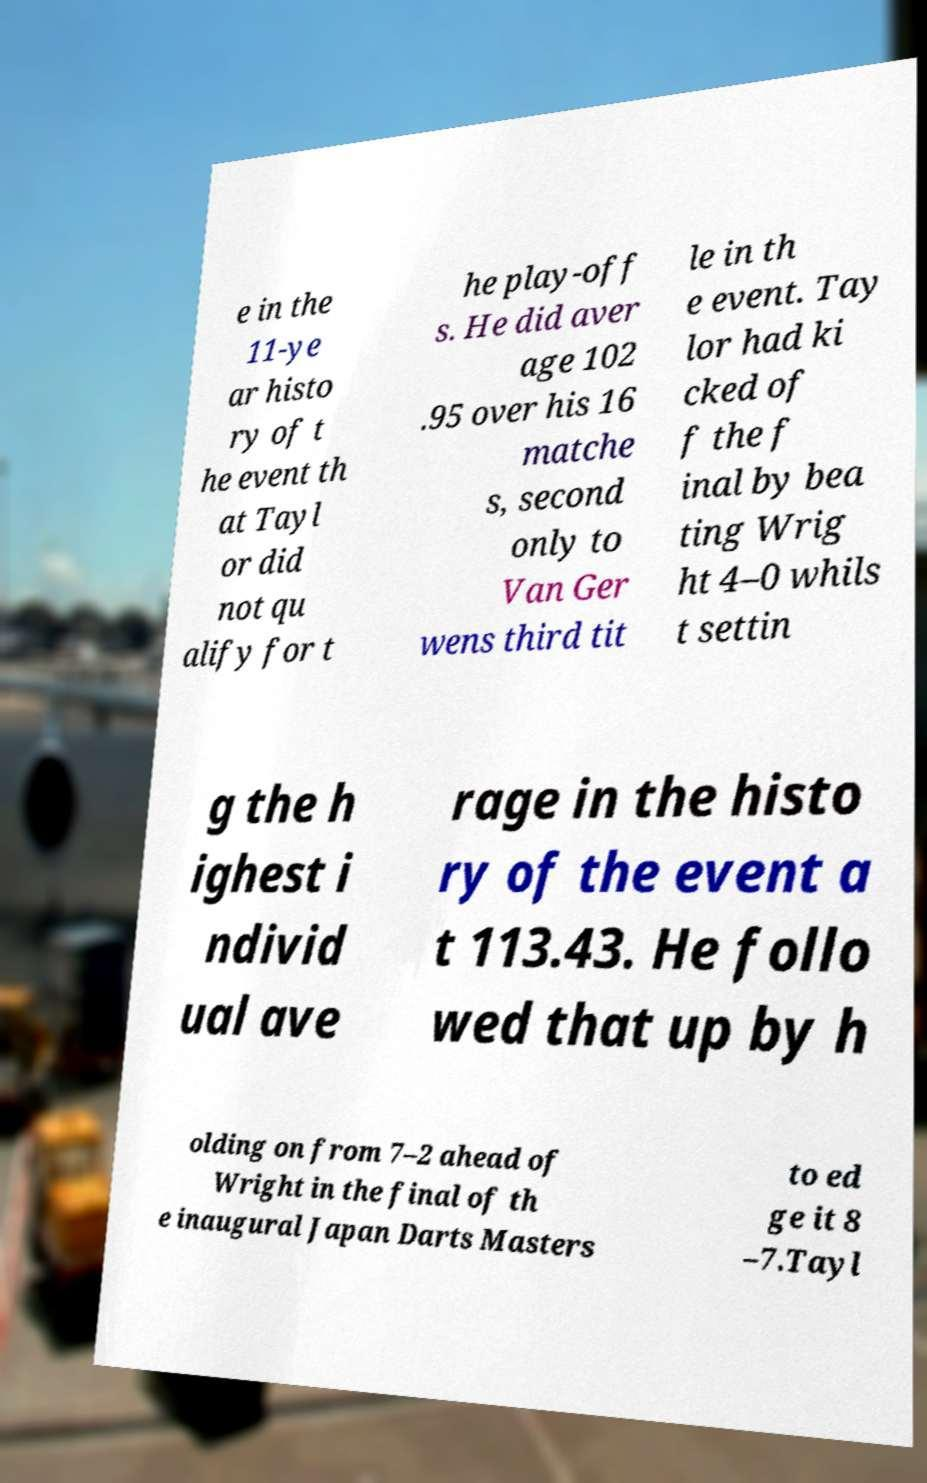Can you accurately transcribe the text from the provided image for me? e in the 11-ye ar histo ry of t he event th at Tayl or did not qu alify for t he play-off s. He did aver age 102 .95 over his 16 matche s, second only to Van Ger wens third tit le in th e event. Tay lor had ki cked of f the f inal by bea ting Wrig ht 4–0 whils t settin g the h ighest i ndivid ual ave rage in the histo ry of the event a t 113.43. He follo wed that up by h olding on from 7–2 ahead of Wright in the final of th e inaugural Japan Darts Masters to ed ge it 8 –7.Tayl 